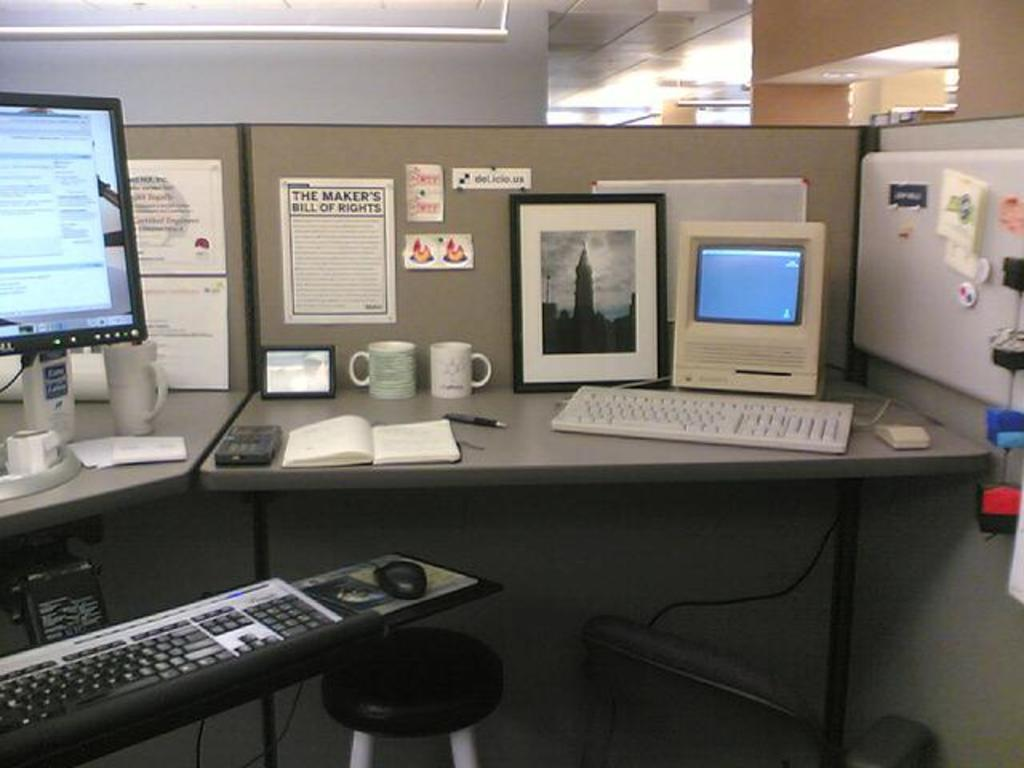<image>
Give a short and clear explanation of the subsequent image. a cubicle with a couple computers has the makers bill of rights hanging up 